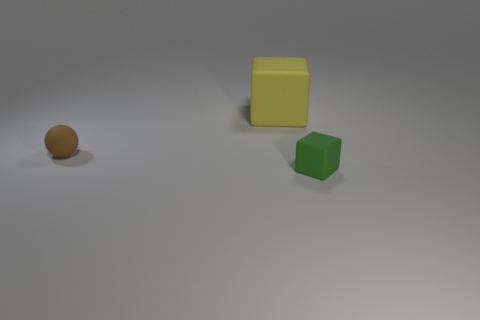Do the object that is to the right of the yellow matte block and the brown object have the same shape?
Offer a very short reply. No. How many balls have the same material as the big object?
Keep it short and to the point. 1. What number of things are objects that are in front of the big thing or big yellow matte balls?
Give a very brief answer. 2. The green matte cube has what size?
Make the answer very short. Small. There is a block that is behind the rubber cube that is in front of the large block; what is its material?
Provide a succinct answer. Rubber. There is a thing that is in front of the matte ball; is it the same size as the yellow thing?
Your response must be concise. No. Are there any small rubber cubes of the same color as the small rubber ball?
Keep it short and to the point. No. How many objects are either objects that are on the right side of the yellow rubber object or blocks right of the yellow rubber thing?
Provide a short and direct response. 1. Are there fewer tiny brown objects that are behind the tiny brown ball than tiny matte objects that are right of the large object?
Keep it short and to the point. Yes. There is a rubber object that is in front of the yellow matte object and to the right of the brown object; what is its size?
Your answer should be very brief. Small. 